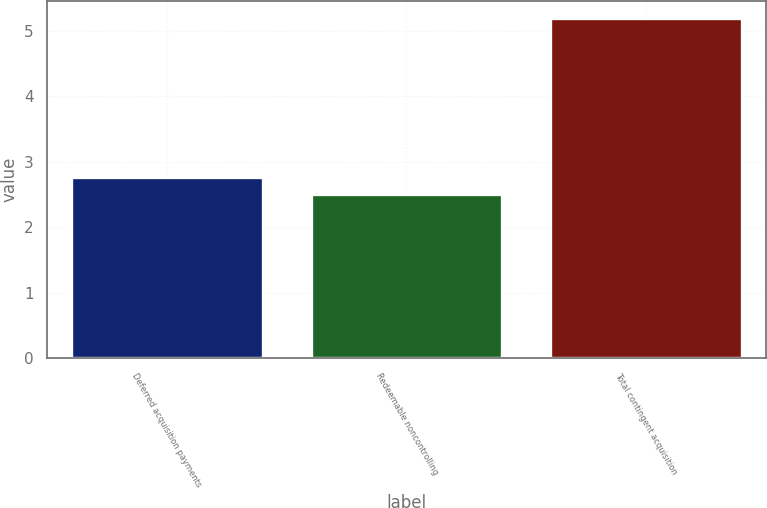<chart> <loc_0><loc_0><loc_500><loc_500><bar_chart><fcel>Deferred acquisition payments<fcel>Redeemable noncontrolling<fcel>Total contingent acquisition<nl><fcel>2.77<fcel>2.5<fcel>5.2<nl></chart> 